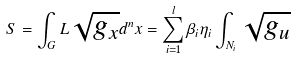Convert formula to latex. <formula><loc_0><loc_0><loc_500><loc_500>S = \int _ { G } L \sqrt { g _ { x } } d ^ { n } x = \sum _ { i = 1 } ^ { l } \beta _ { i } \eta _ { i } \int _ { N _ { i } } \sqrt { g _ { u } }</formula> 